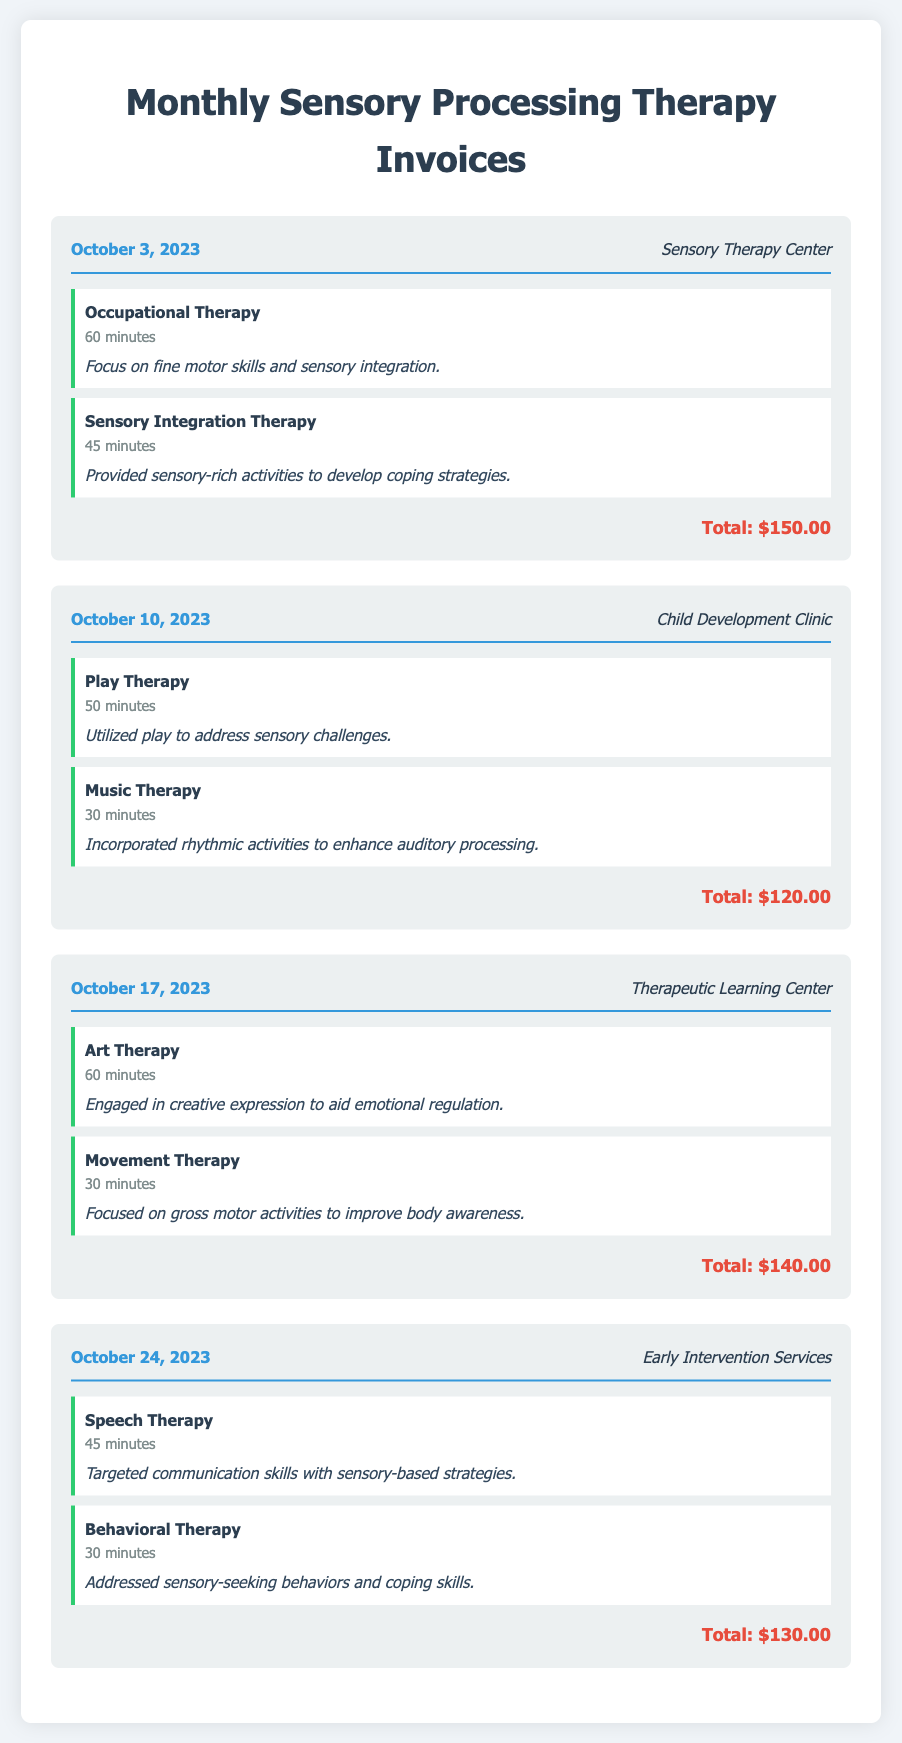what is the total amount for the October 3, 2023 invoice? The total amount is stated at the bottom of the invoice for that date, which is $150.00.
Answer: $150.00 who is the provider for the October 10, 2023 session? The provider is listed in the invoice header for that date, which is Child Development Clinic.
Answer: Child Development Clinic how long was the Music Therapy session on October 10, 2023? The duration of the Music Therapy session is specified in the therapy section of that invoice, which is 30 minutes.
Answer: 30 minutes which therapy focuses on emotional regulation? The therapy that focuses on emotional regulation is noted in the invoice for October 17, 2023, which is Art Therapy.
Answer: Art Therapy how many different therapies were provided on October 24, 2023? The number of different therapies is determined by counting the therapies listed in that invoice, which includes two therapies.
Answer: two what type of therapy was included on October 17, 2023? The types of therapy can be found in the invoice, which include Art Therapy and Movement Therapy for that date.
Answer: Art Therapy, Movement Therapy what is the total for the October 24, 2023 invoice? The total amount is clearly indicated at the bottom of the invoice for that date, which is $130.00.
Answer: $130.00 what was the focus of the therapy on October 3, 2023? The focus of the therapies is mentioned in the therapy notes for that date, indicating fine motor skills and sensory integration.
Answer: fine motor skills and sensory integration 